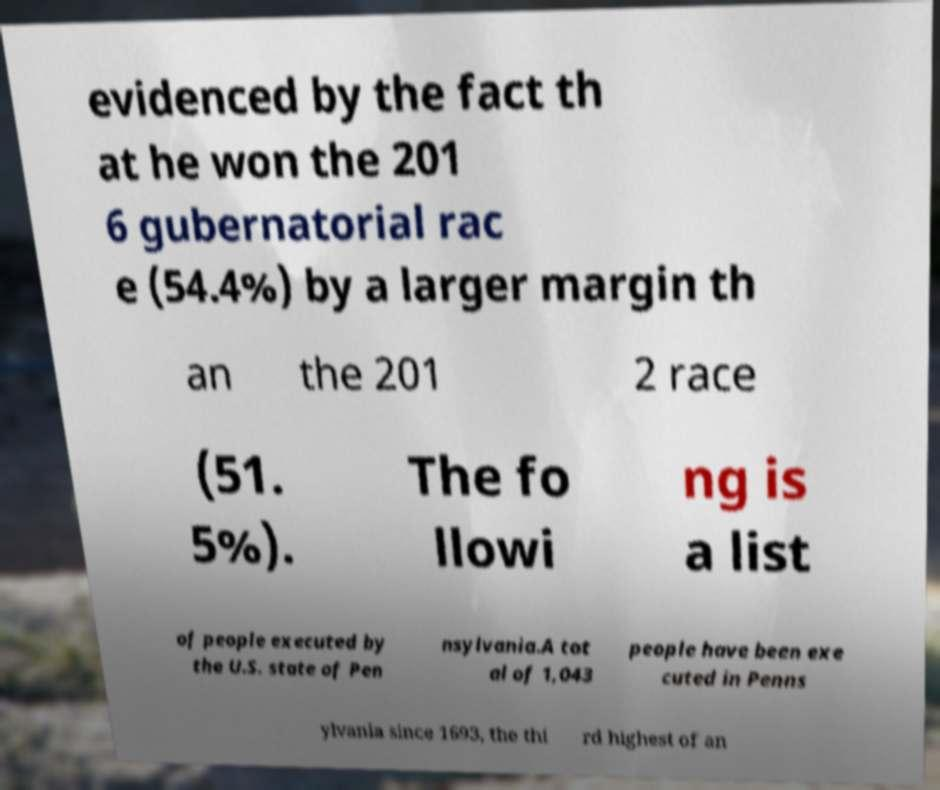Can you read and provide the text displayed in the image?This photo seems to have some interesting text. Can you extract and type it out for me? evidenced by the fact th at he won the 201 6 gubernatorial rac e (54.4%) by a larger margin th an the 201 2 race (51. 5%). The fo llowi ng is a list of people executed by the U.S. state of Pen nsylvania.A tot al of 1,043 people have been exe cuted in Penns ylvania since 1693, the thi rd highest of an 